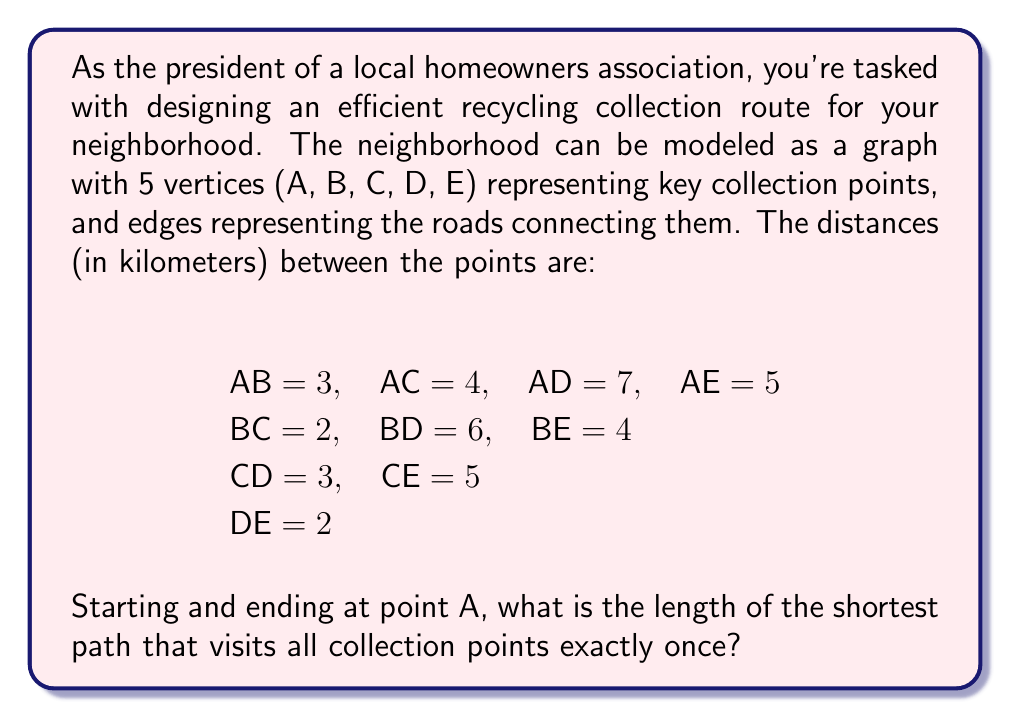Provide a solution to this math problem. This problem is an instance of the Traveling Salesman Problem (TSP) in graph theory. To solve it, we need to find the shortest Hamiltonian cycle in the given graph.

Given the small number of vertices, we can solve this using a brute-force approach:

1) List all possible permutations of the vertices B, C, D, E.
2) For each permutation, calculate the total distance of the path starting and ending at A.
3) Choose the permutation with the shortest total distance.

Possible permutations:
1. ABCDEA
2. ABCEDA
3. ABDCEA
4. ABDECA
5. ABEDCA
6. ABECDA
7. ACBDEA
8. ACBEDA
9. ACDBEA
10. ACDEBA
11. ACEDBDA
12. ACEDBA

Let's calculate the distance for each:

1. ABCDEA: 3 + 2 + 3 + 2 + 5 = 15
2. ABCEDA: 3 + 2 + 5 + 2 + 5 = 17
3. ABDCEA: 3 + 6 + 3 + 5 + 5 = 22
4. ABDECA: 3 + 6 + 2 + 5 + 5 = 21
5. ABEDCA: 3 + 4 + 2 + 3 + 4 = 16
6. ABECDA: 3 + 4 + 5 + 3 + 4 = 19
7. ACBDEA: 4 + 2 + 6 + 2 + 5 = 19
8. ACBEDA: 4 + 2 + 4 + 2 + 5 = 17
9. ACDEBA: 4 + 3 + 2 + 4 + 5 = 18
10. ACEDBDA: 4 + 5 + 2 + 6 + 3 = 20
11. ACEDBA: 4 + 5 + 2 + 4 + 3 = 18

The shortest path is ABCDEA with a total length of 15 km.
Answer: The length of the shortest path that visits all collection points exactly once, starting and ending at point A, is 15 km. 